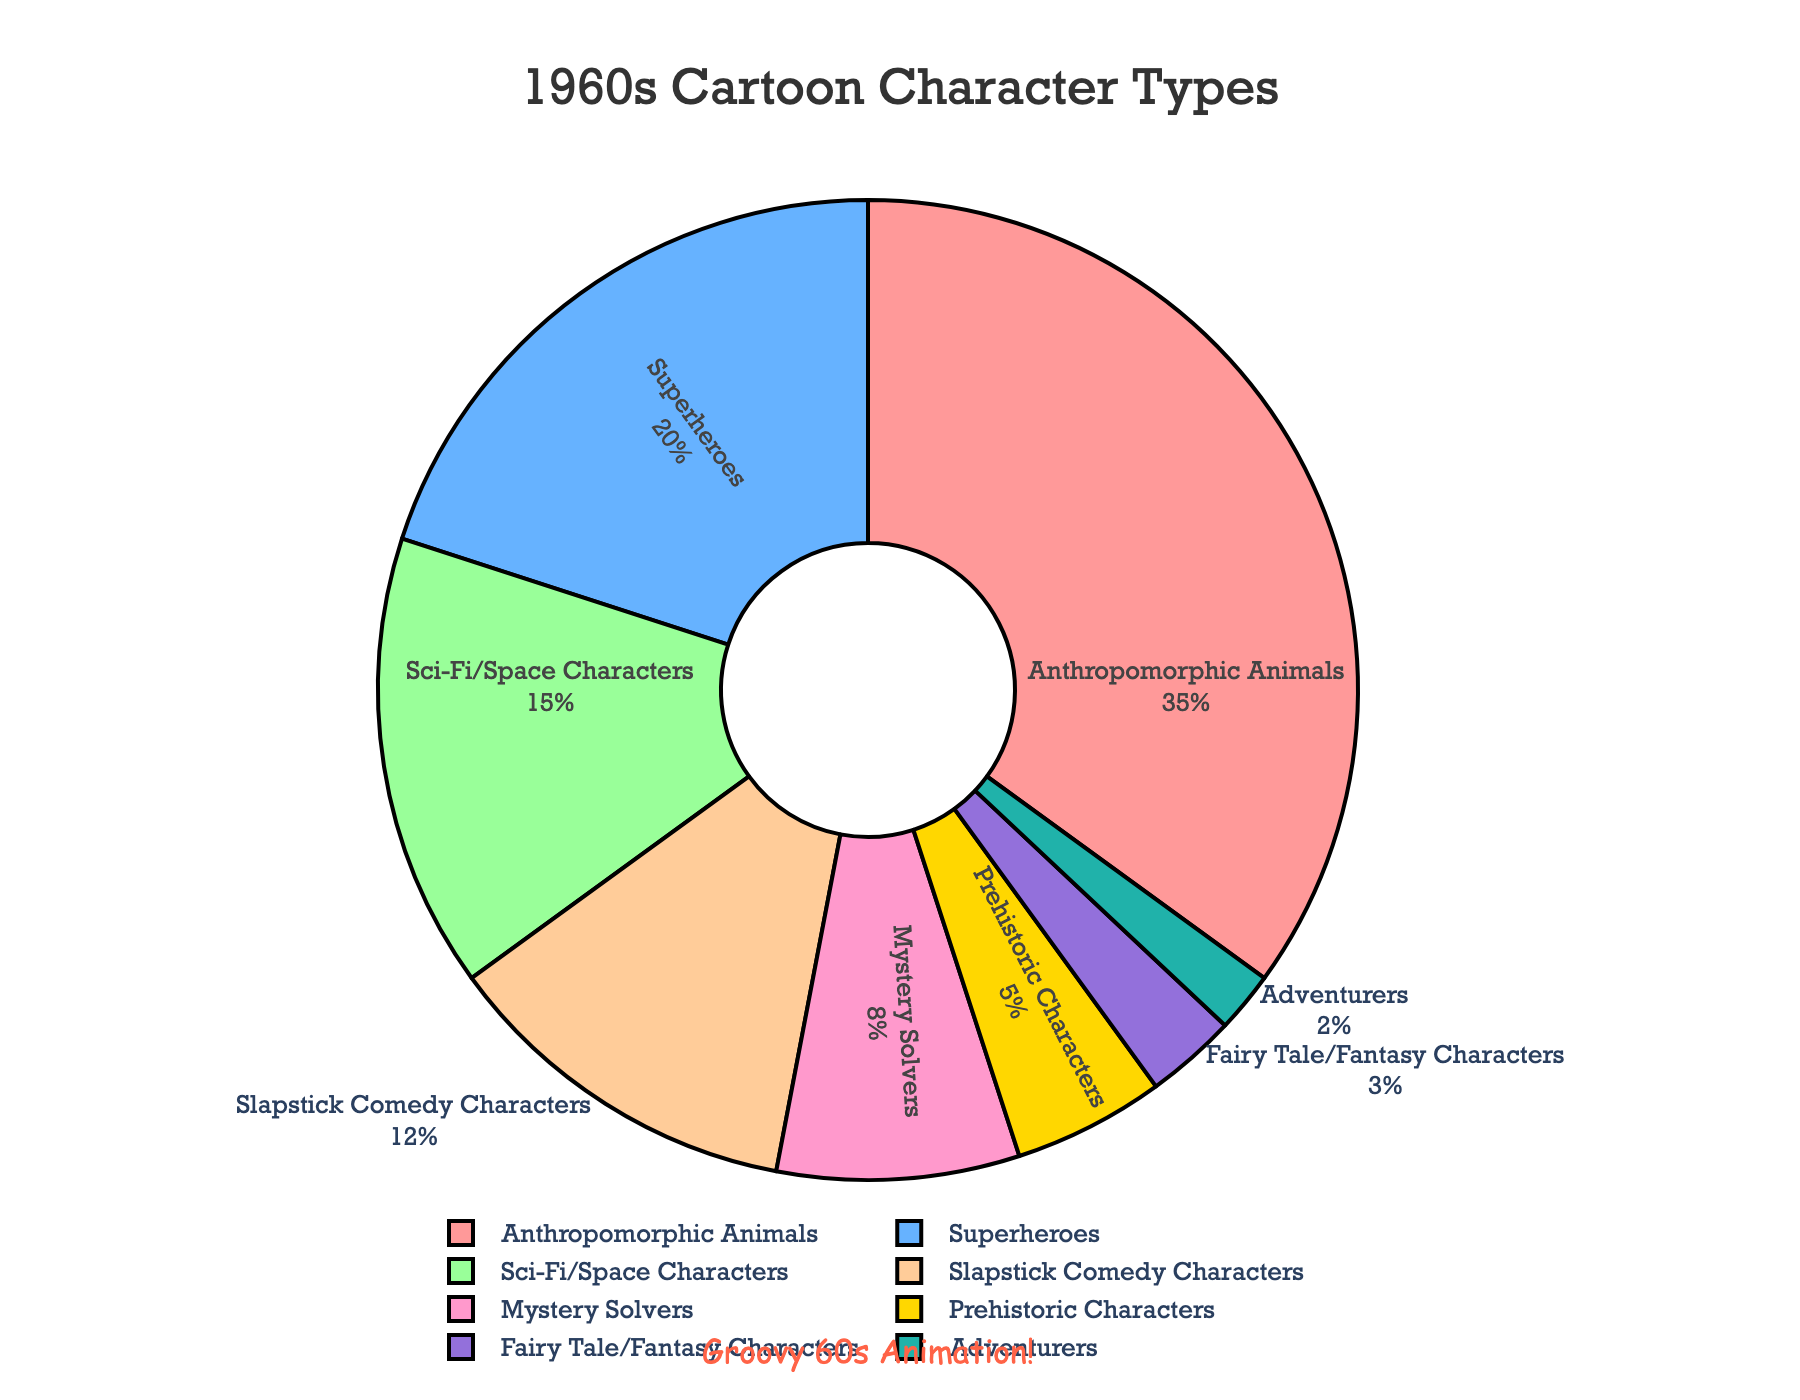What's the most common 1960s cartoon character type? To find the most common cartoon character type, look for the character type with the highest percentage on the pie chart. Anthropomorphic Animals have the highest percentage.
Answer: Anthropomorphic Animals Which character type has a higher percentage, Superheroes or Sci-Fi/Space Characters? Compare the percentages of Superheroes (20%) and Sci-Fi/Space Characters (15%). Since 20% is greater than 15%, Superheroes have a higher percentage.
Answer: Superheroes What is the combined percentage of Slapstick Comedy Characters and Mystery Solvers? To calculate the combined percentage, add the percentages of Slapstick Comedy Characters (12%) and Mystery Solvers (8%). 12% + 8% equals 20%.
Answer: 20% Which character types together make up more than half of the chart? Sum up the percentages of different character types to find the combinations that exceed 50%. Anthropomorphic Animals (35%) and Superheroes (20%) sum to 55%, which is more than half.
Answer: Anthropomorphic Animals and Superheroes How much larger is the percentage of Anthropomorphic Animals compared to Fairy Tale/Fantasy Characters? Subtract the percentage of Fairy Tale/Fantasy Characters (3%) from the percentage of Anthropomorphic Animals (35%). 35% - 3% equals 32%.
Answer: 32% Which two character types have the smallest percentages? Identify the two character types with the smallest segments in the pie chart. Adventurers (2%) and Fairy Tale/Fantasy Characters (3%) are the smallest.
Answer: Adventurers and Fairy Tale/Fantasy Characters What percentage of the chart is made up of Prehistoric Characters and Adventurers combined? Add the percentages of Prehistoric Characters (5%) and Adventurers (2%). 5% + 2% equals 7%.
Answer: 7% How does the percentage of Mystery Solvers compare to Prehistoric Characters? Compare the percentages of Mystery Solvers (8%) and Prehistoric Characters (5%). 8% is greater than 5%.
Answer: Mystery Solvers are higher What's the total percentage of character types that have less than 10% each? Identify the character types with less than 10% each: Mystery Solvers (8%), Prehistoric Characters (5%), Fairy Tale/Fantasy Characters (3%), and Adventurers (2%). Add these percentages: 8% + 5% + 3% + 2% equals 18%.
Answer: 18% Which segment of the pie chart is colored blue? Observe the visual attributes such as colors of the pie chart segments. The segment representing Superheroes is colored blue.
Answer: Superheroes 